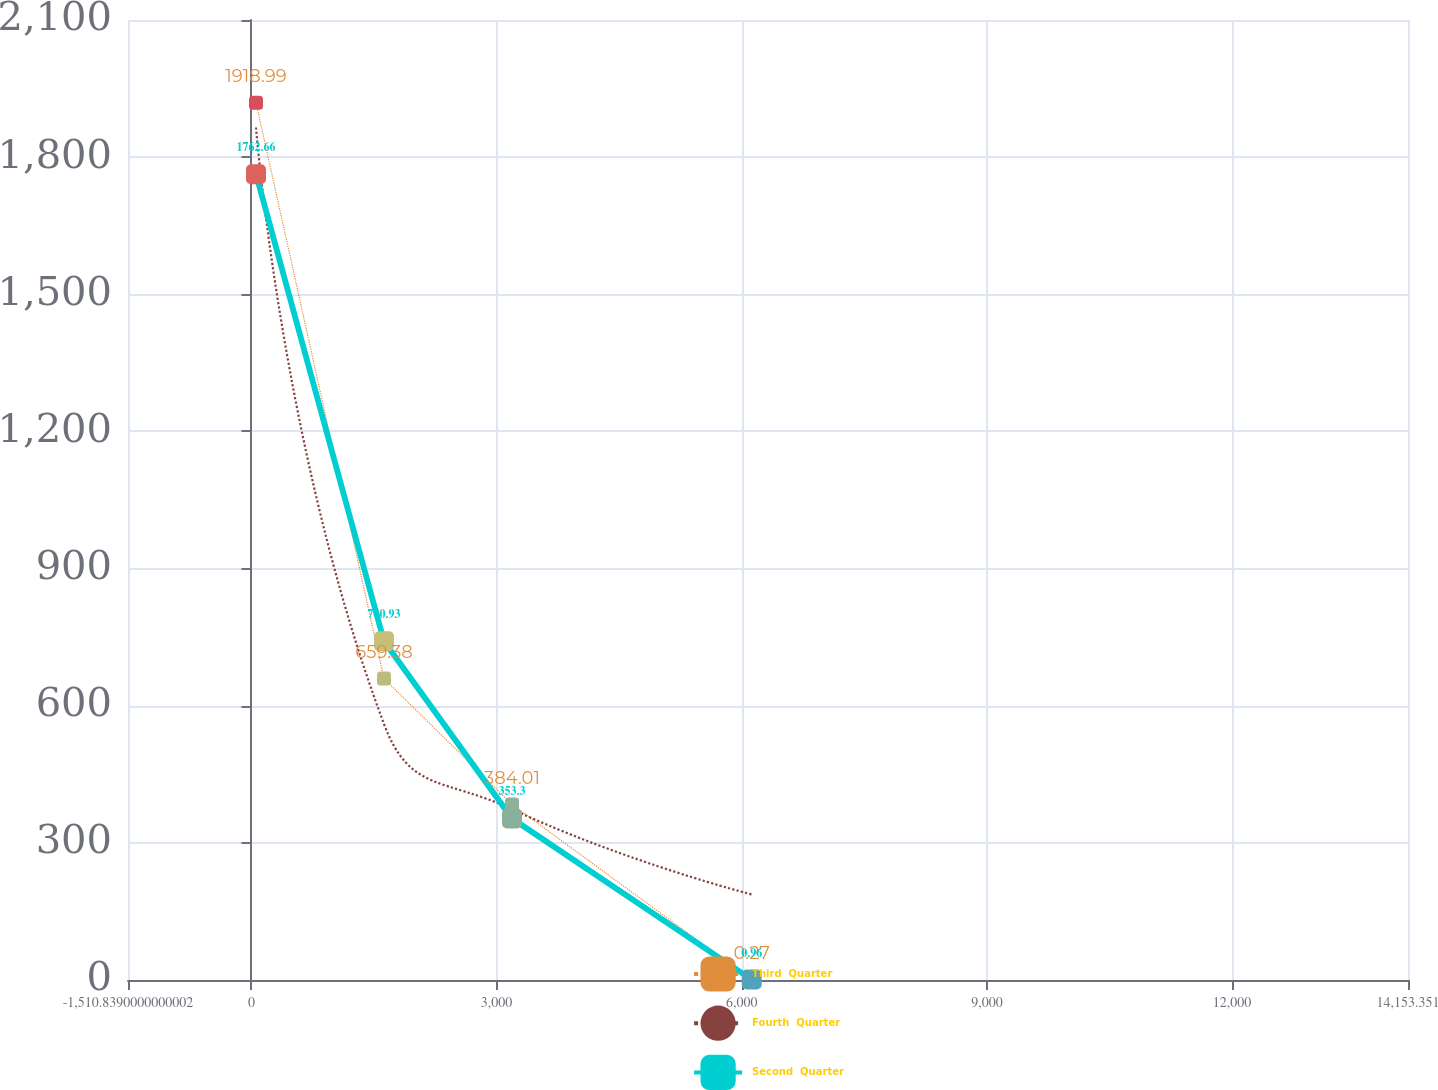Convert chart. <chart><loc_0><loc_0><loc_500><loc_500><line_chart><ecel><fcel>Third  Quarter<fcel>Fourth  Quarter<fcel>Second  Quarter<nl><fcel>55.58<fcel>1918.99<fcel>1864.85<fcel>1762.66<nl><fcel>1622<fcel>659.38<fcel>559.93<fcel>740.93<nl><fcel>3188.42<fcel>384.01<fcel>373.52<fcel>353.3<nl><fcel>6122.08<fcel>0.27<fcel>187.11<fcel>0.96<nl><fcel>15719.8<fcel>192.14<fcel>0.7<fcel>177.13<nl></chart> 